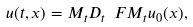<formula> <loc_0><loc_0><loc_500><loc_500>u ( t , x ) = M _ { t } D _ { t } \ F M _ { t } u _ { 0 } ( x ) ,</formula> 